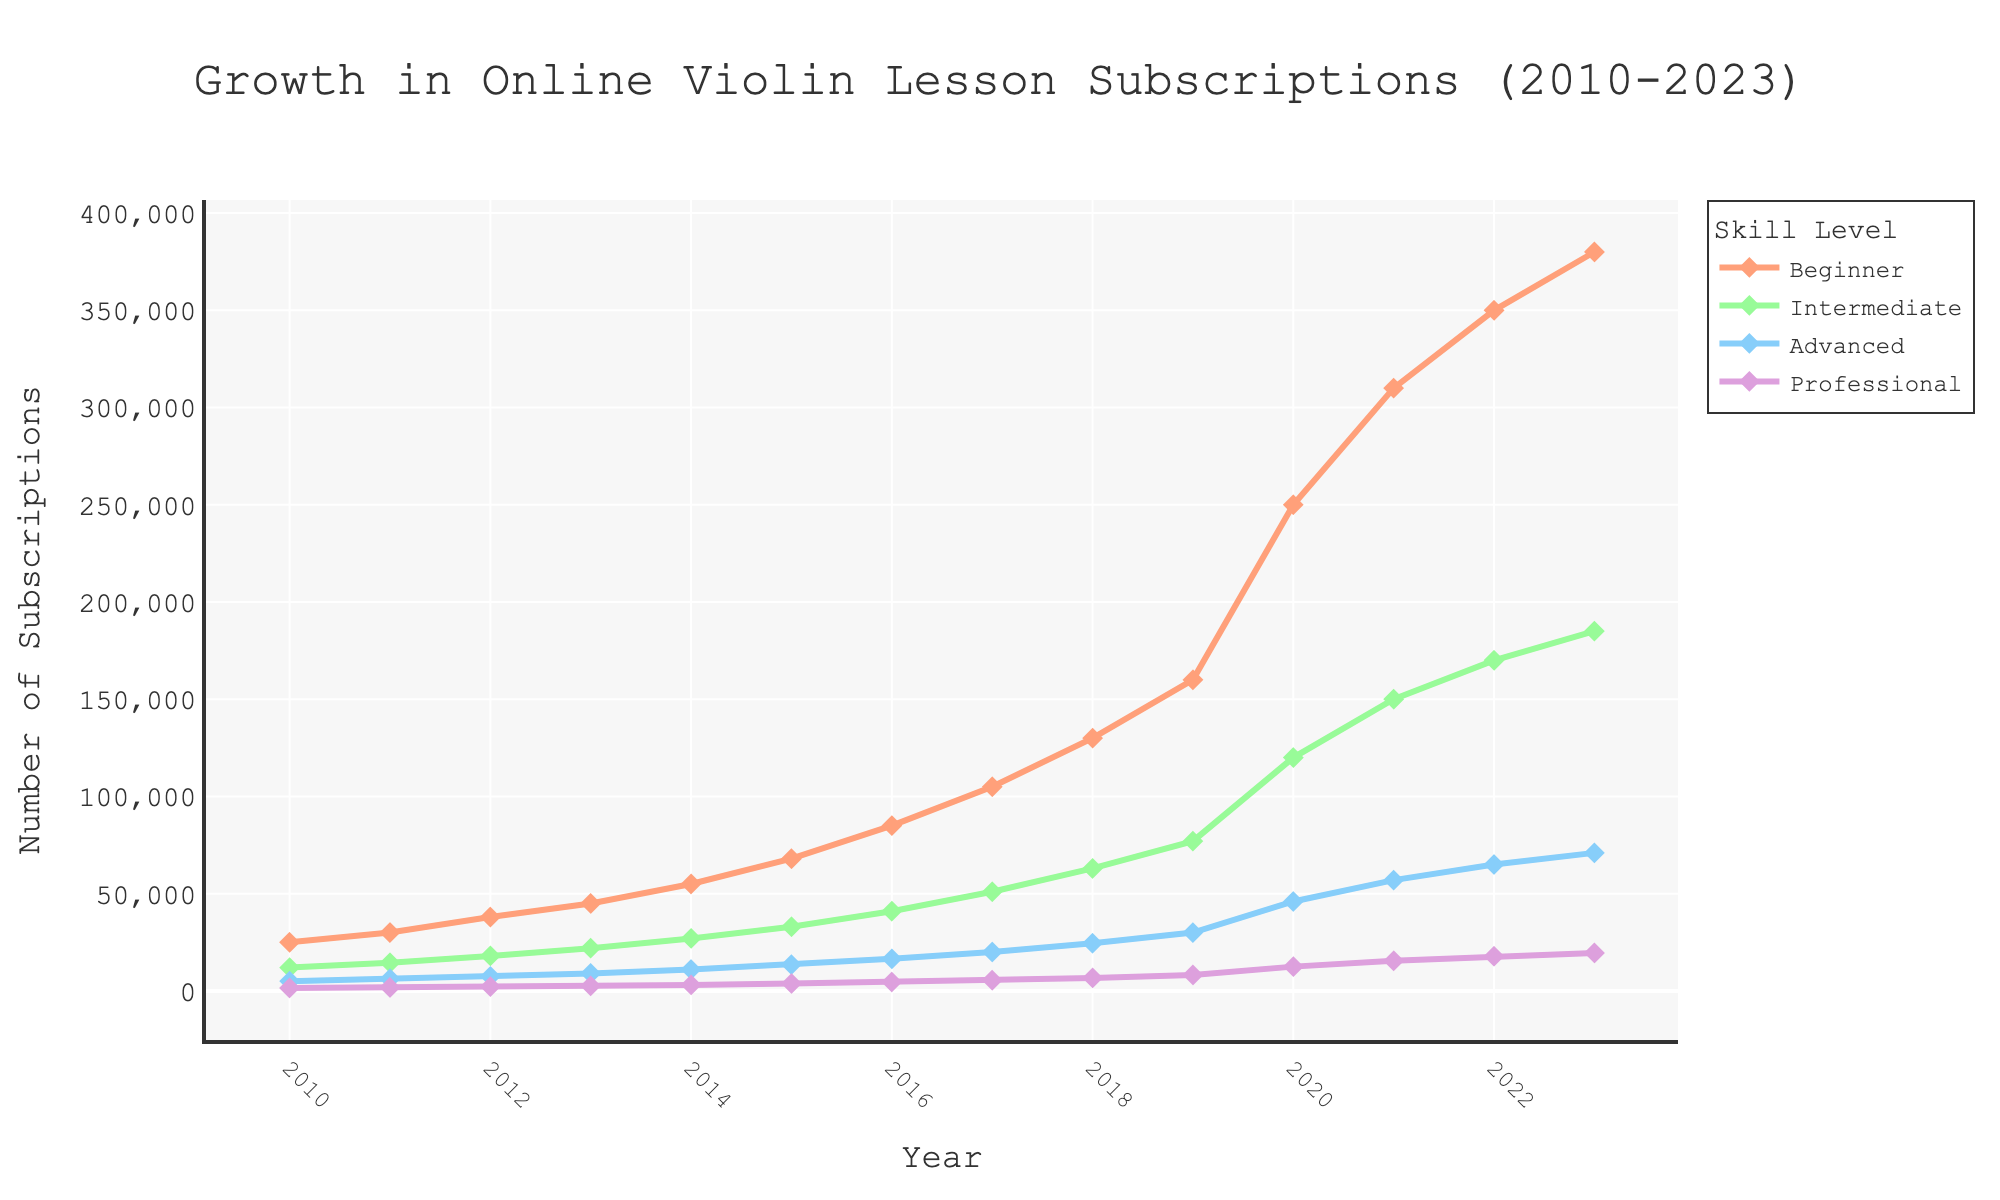Which skill level has shown the highest growth in subscriptions from 2010 to 2023? The beginner skill level starts at 25000 in 2010 and grows to 380000 in 2023, demonstrating the highest growth compared to other skill levels.
Answer: Beginner In which year did the advanced skill level surpass 20000 subscriptions? By examining the figure, the advanced skill level surpasses 20000 subscriptions in 2017.
Answer: 2017 What is the approximate difference in subscriptions between intermediate and beginner levels in 2020? In 2020, the beginner level has around 250000 subscriptions, and the intermediate level has around 120000 subscriptions. The difference is approximately 250000 - 120000 = 130000.
Answer: 130000 Which skill level had the smallest number of subscriptions in 2013? In 2013, the professional skill level has the smallest number of subscriptions, with only about 2600.
Answer: Professional Compare the growth trends of intermediate and professional skill levels from 2010 to 2023. Which is steeper? Observing the trends for intermediate and professional levels, the intermediate skill level shows a much steeper growth trend, increasing significantly more in number compared to the professional level.
Answer: Intermediate What is the combined total of subscriptions for all skill levels in 2015? Adding up the subscriptions for all skill levels in 2015: Beginner: 68000, Intermediate: 33000, Advanced: 13500, Professional: 3800. The total is 68000 + 33000 + 13500 + 3800 = 118300.
Answer: 118300 Which year shows the largest increase in beginner subscriptions compared to the previous year? The largest increase in beginner subscriptions happens between 2019 and 2020, where subscriptions jump from 160000 to 250000.
Answer: 2019-2020 What is the ratio of advanced to professional subscriptions in 2023? In 2023, the advanced skill level has 71000 subscriptions, and the professional skill level has 19500 subscriptions. The ratio is 71000 / 19500 ≈ 3.64.
Answer: 3.64 How does the number of subscriptions for the intermediate level in 2011 compare to the advanced level in 2014? The intermediate level in 2011 has 14500 subscriptions, while the advanced level in 2014 has 11000 subscriptions. Therefore, the intermediate level in 2011 has 3500 more subscriptions.
Answer: 3500 more 